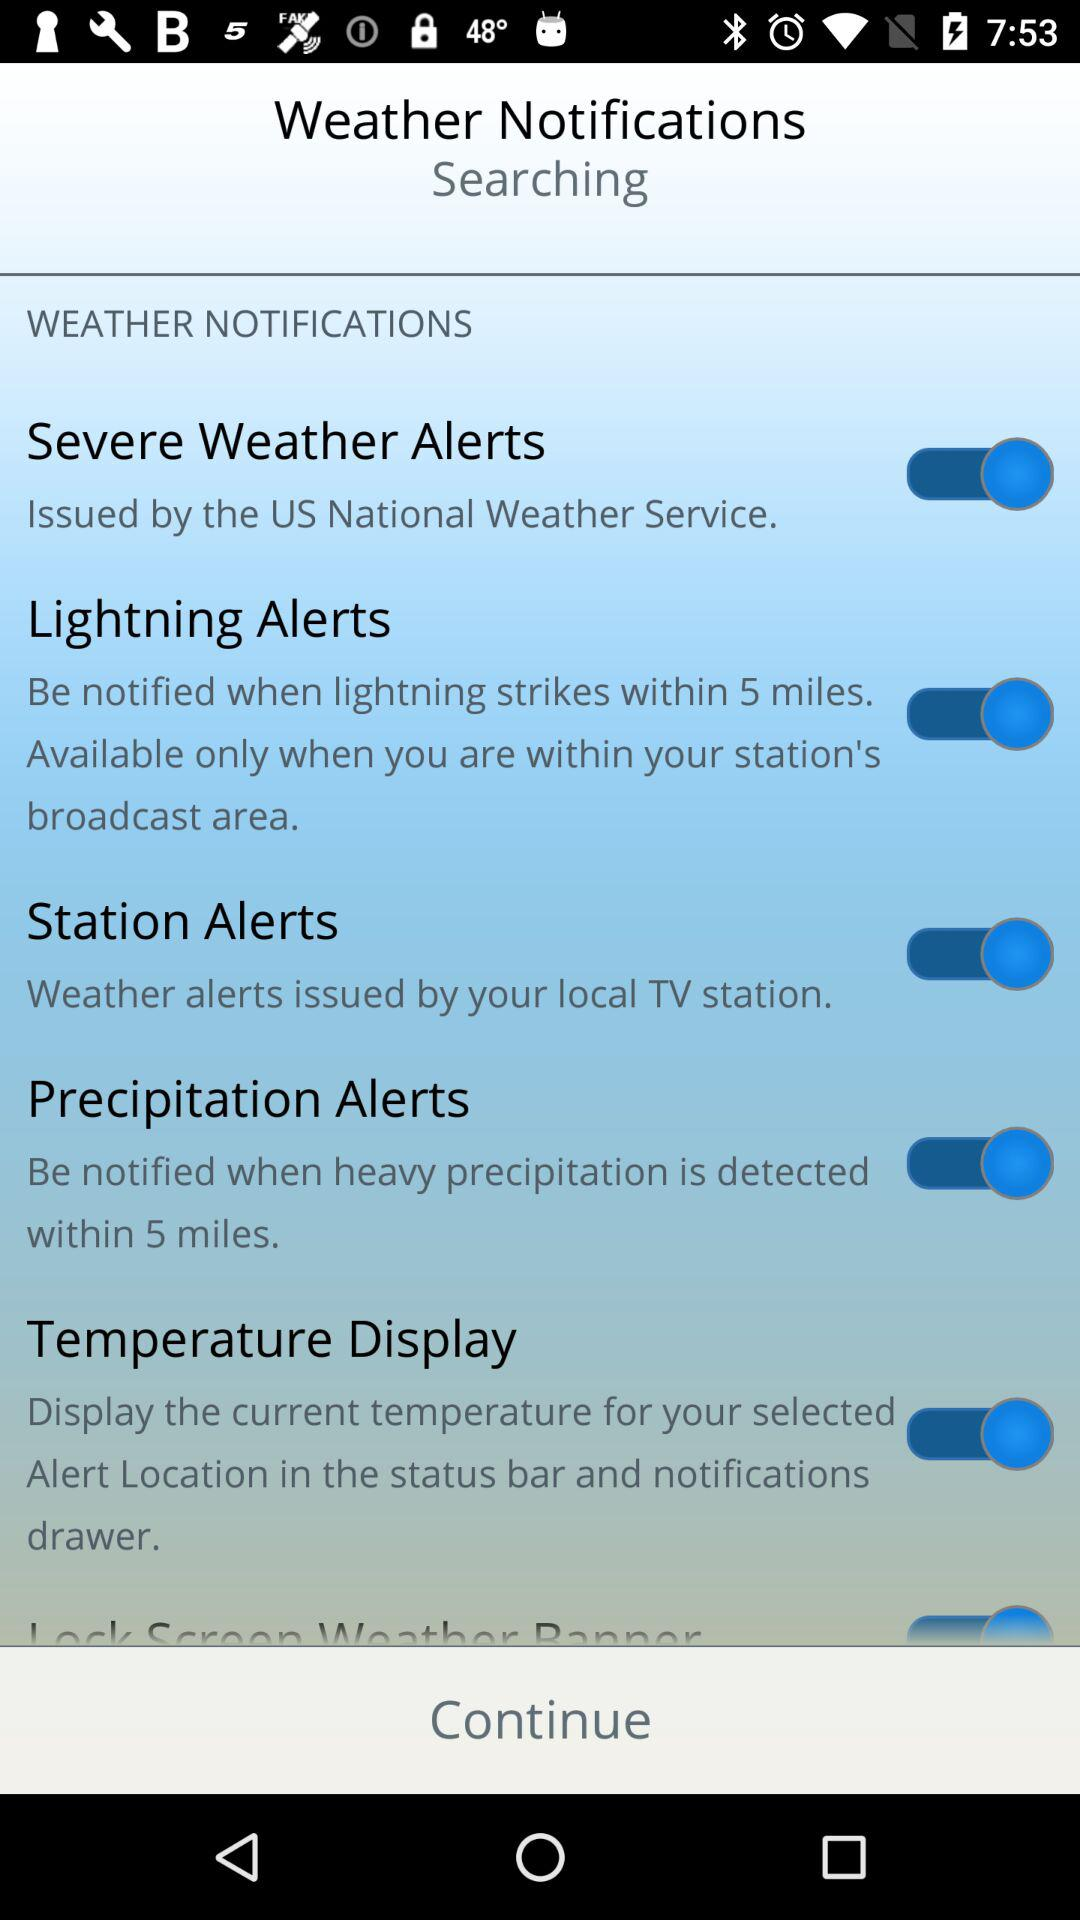What's the radius of precipitation alerts? The radius of precipitation alerts is 5 miles. 